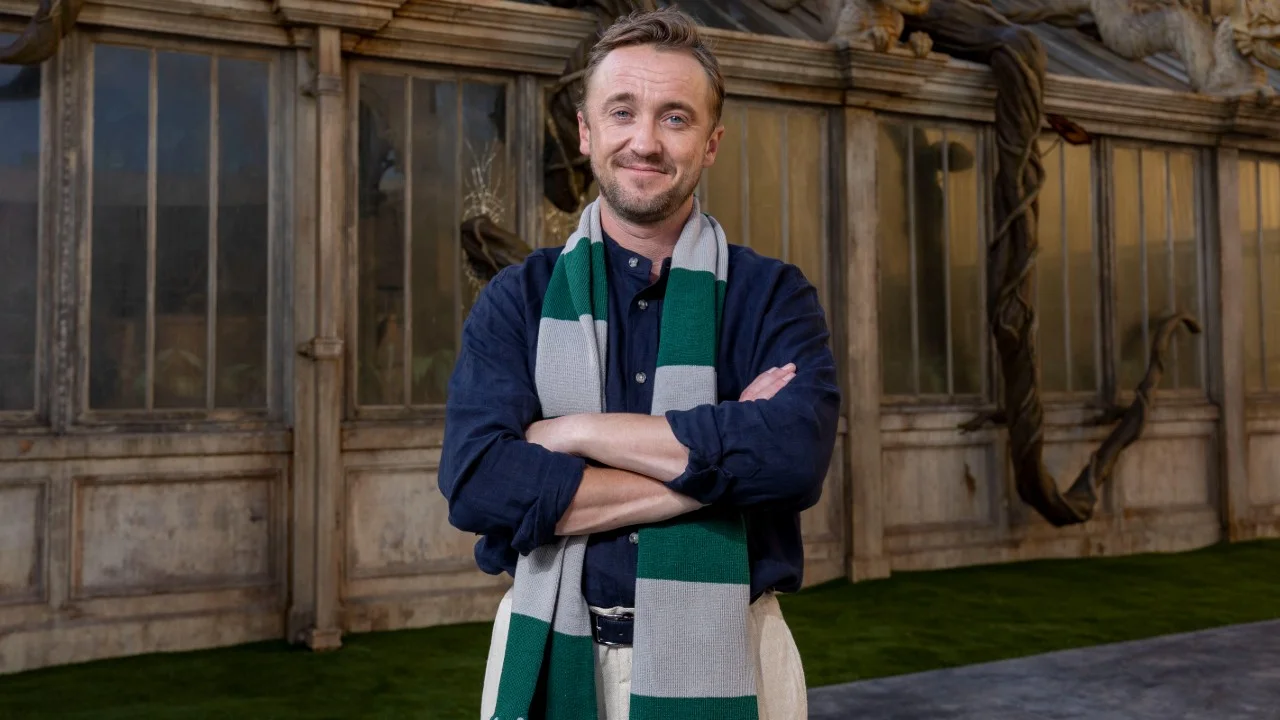What might be the story behind the character's expression and posture? The story behind the character’s relaxed yet firm posture and thoughtful expression could be one of reflection after a long journey. Perhaps he has just returned from a quest that tested his resolve and strength, and now stands before a place of great personal significance. The slight smile indicates satisfaction or a sense of accomplishment, while his crossed arms suggest a readiness to face any future challenges. The setting around him, reminiscent of a historic or culturally rich location, might be a place of sanctuary where he finds solace and clarity, allowing him to contemplate his next steps or simply enjoy a moment of peace. 